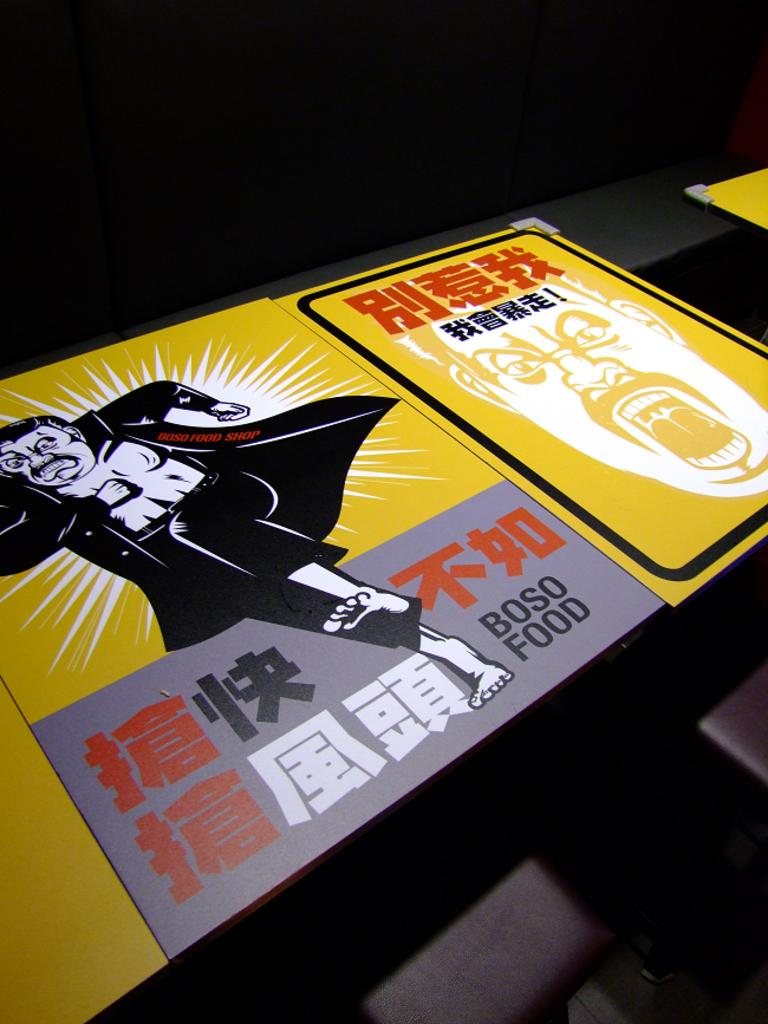<image>
Relay a brief, clear account of the picture shown. Boso Food Shop uses high contrast and high energy imagery to advertise. 